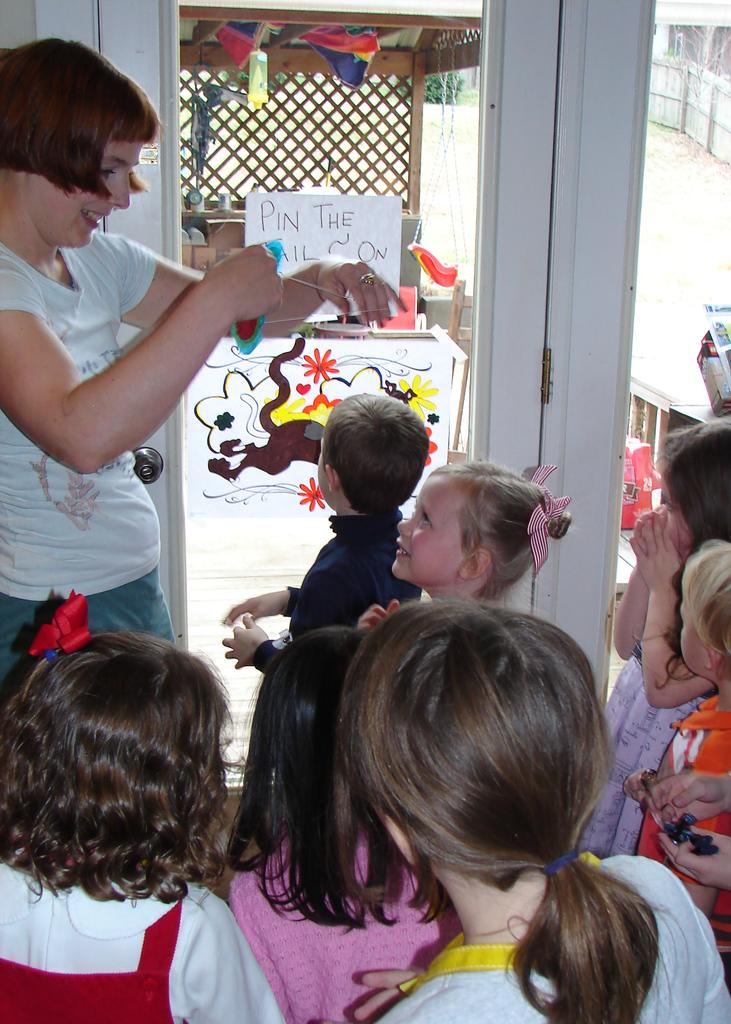How many people are standing in the image? There are kids and a woman standing in the image, making a total of at least two people. What is the woman holding in the image? The woman is holding an object in the image. What can be seen on the door in the image? There are papers stuck to the door in the image. What can be seen in the background of the image? There are items and a plant visible in the background of the image. Can you tell me how many ears the zebra has in the image? There is no zebra present in the image, so it is not possible to determine the number of ears it might have. 